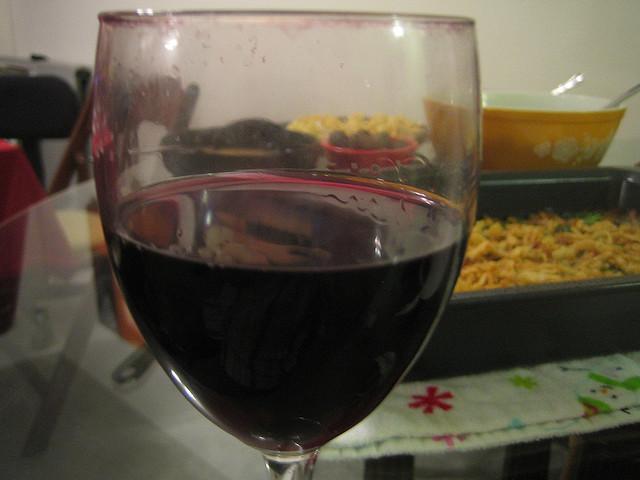How many glasses of wine are in the picture?
Give a very brief answer. 1. How many dining tables are in the photo?
Give a very brief answer. 2. How many bowls can you see?
Give a very brief answer. 3. 